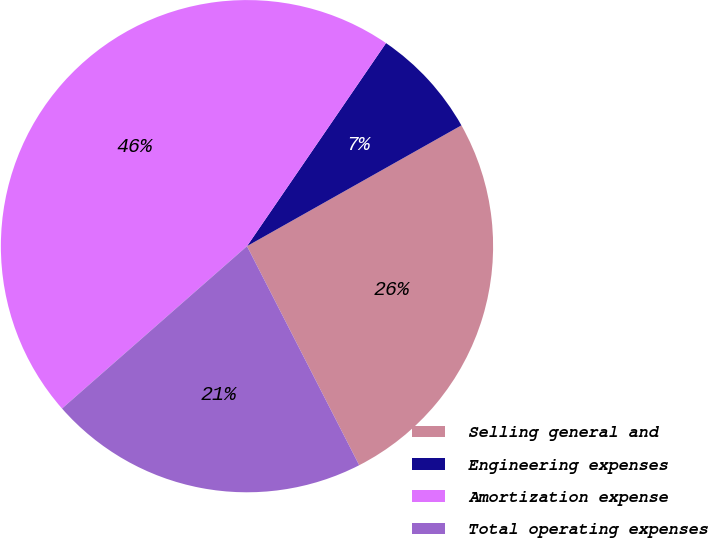Convert chart. <chart><loc_0><loc_0><loc_500><loc_500><pie_chart><fcel>Selling general and<fcel>Engineering expenses<fcel>Amortization expense<fcel>Total operating expenses<nl><fcel>25.63%<fcel>7.28%<fcel>46.02%<fcel>21.07%<nl></chart> 